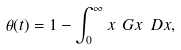<formula> <loc_0><loc_0><loc_500><loc_500>\theta ( t ) = 1 - \int _ { 0 } ^ { \infty } x \ G { x } \ D x ,</formula> 